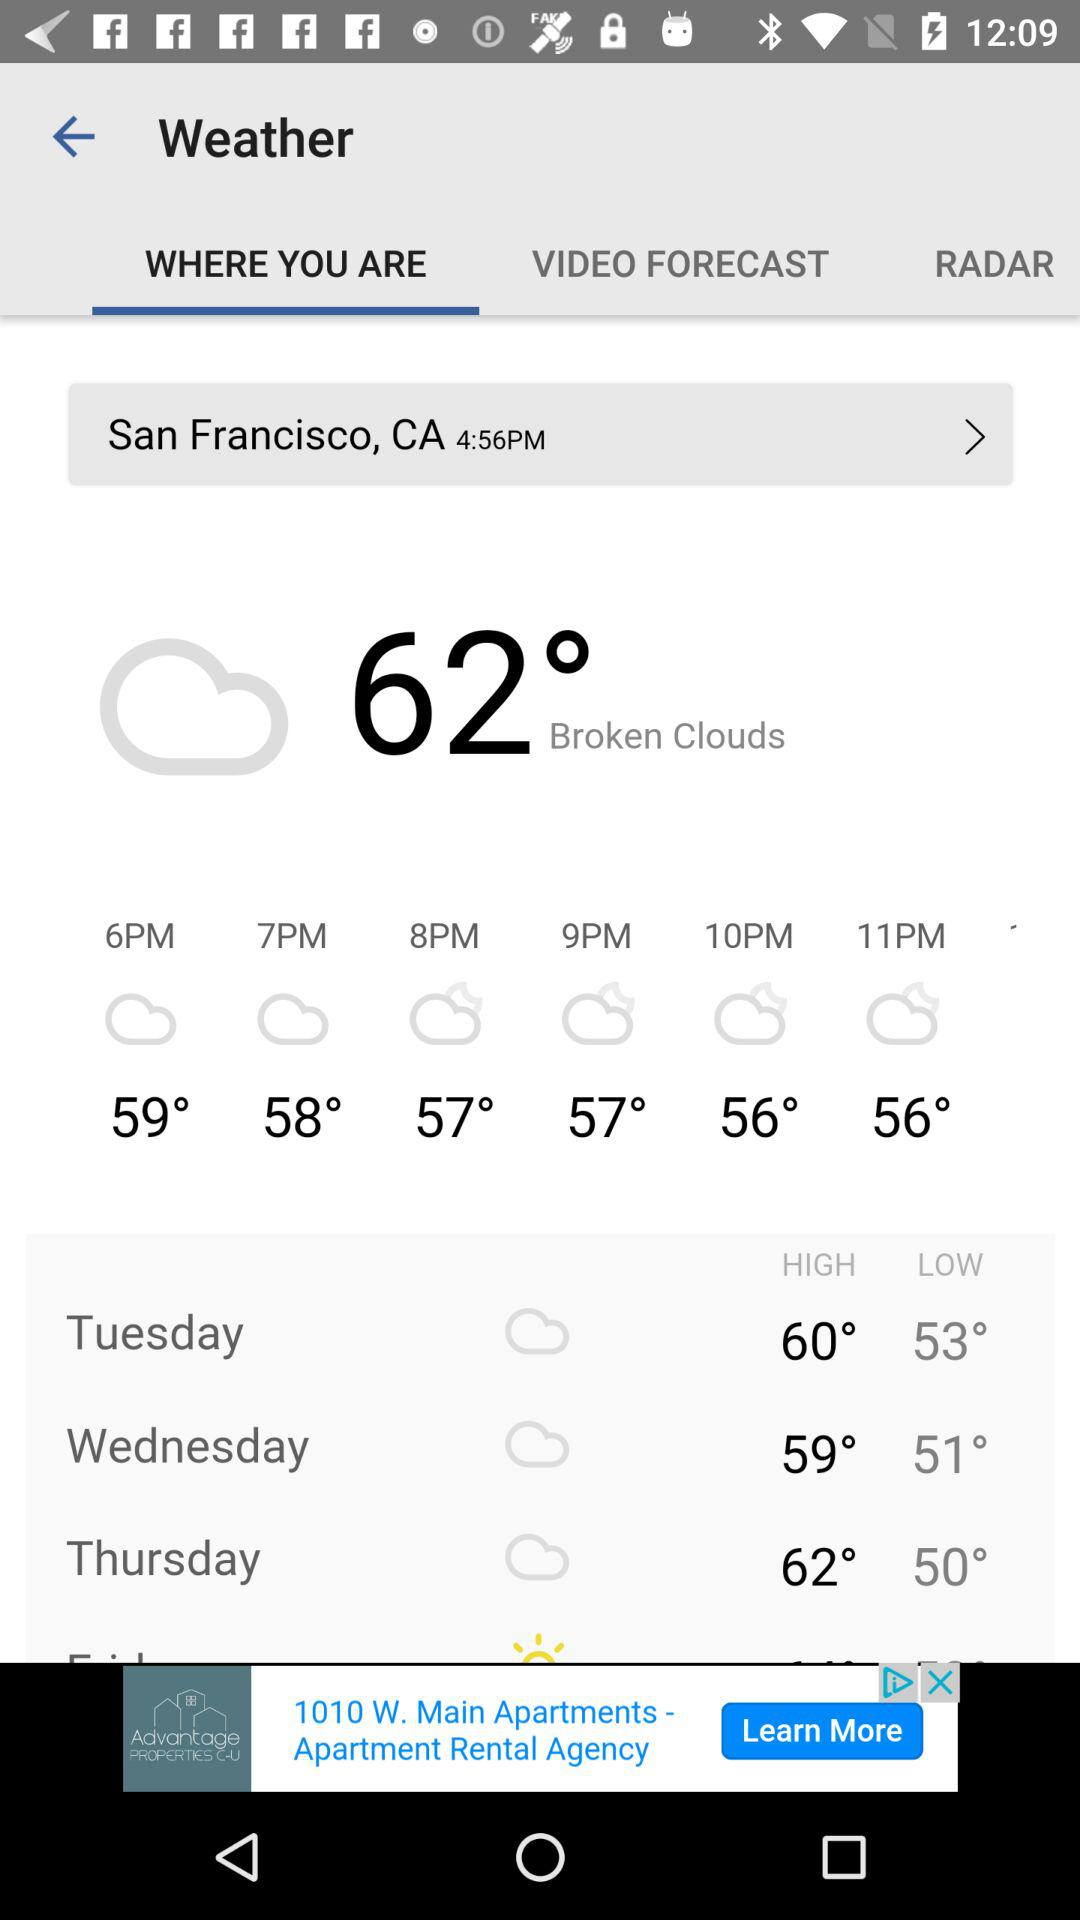What is the time? The times are 12:09 and 4:56 PM. 